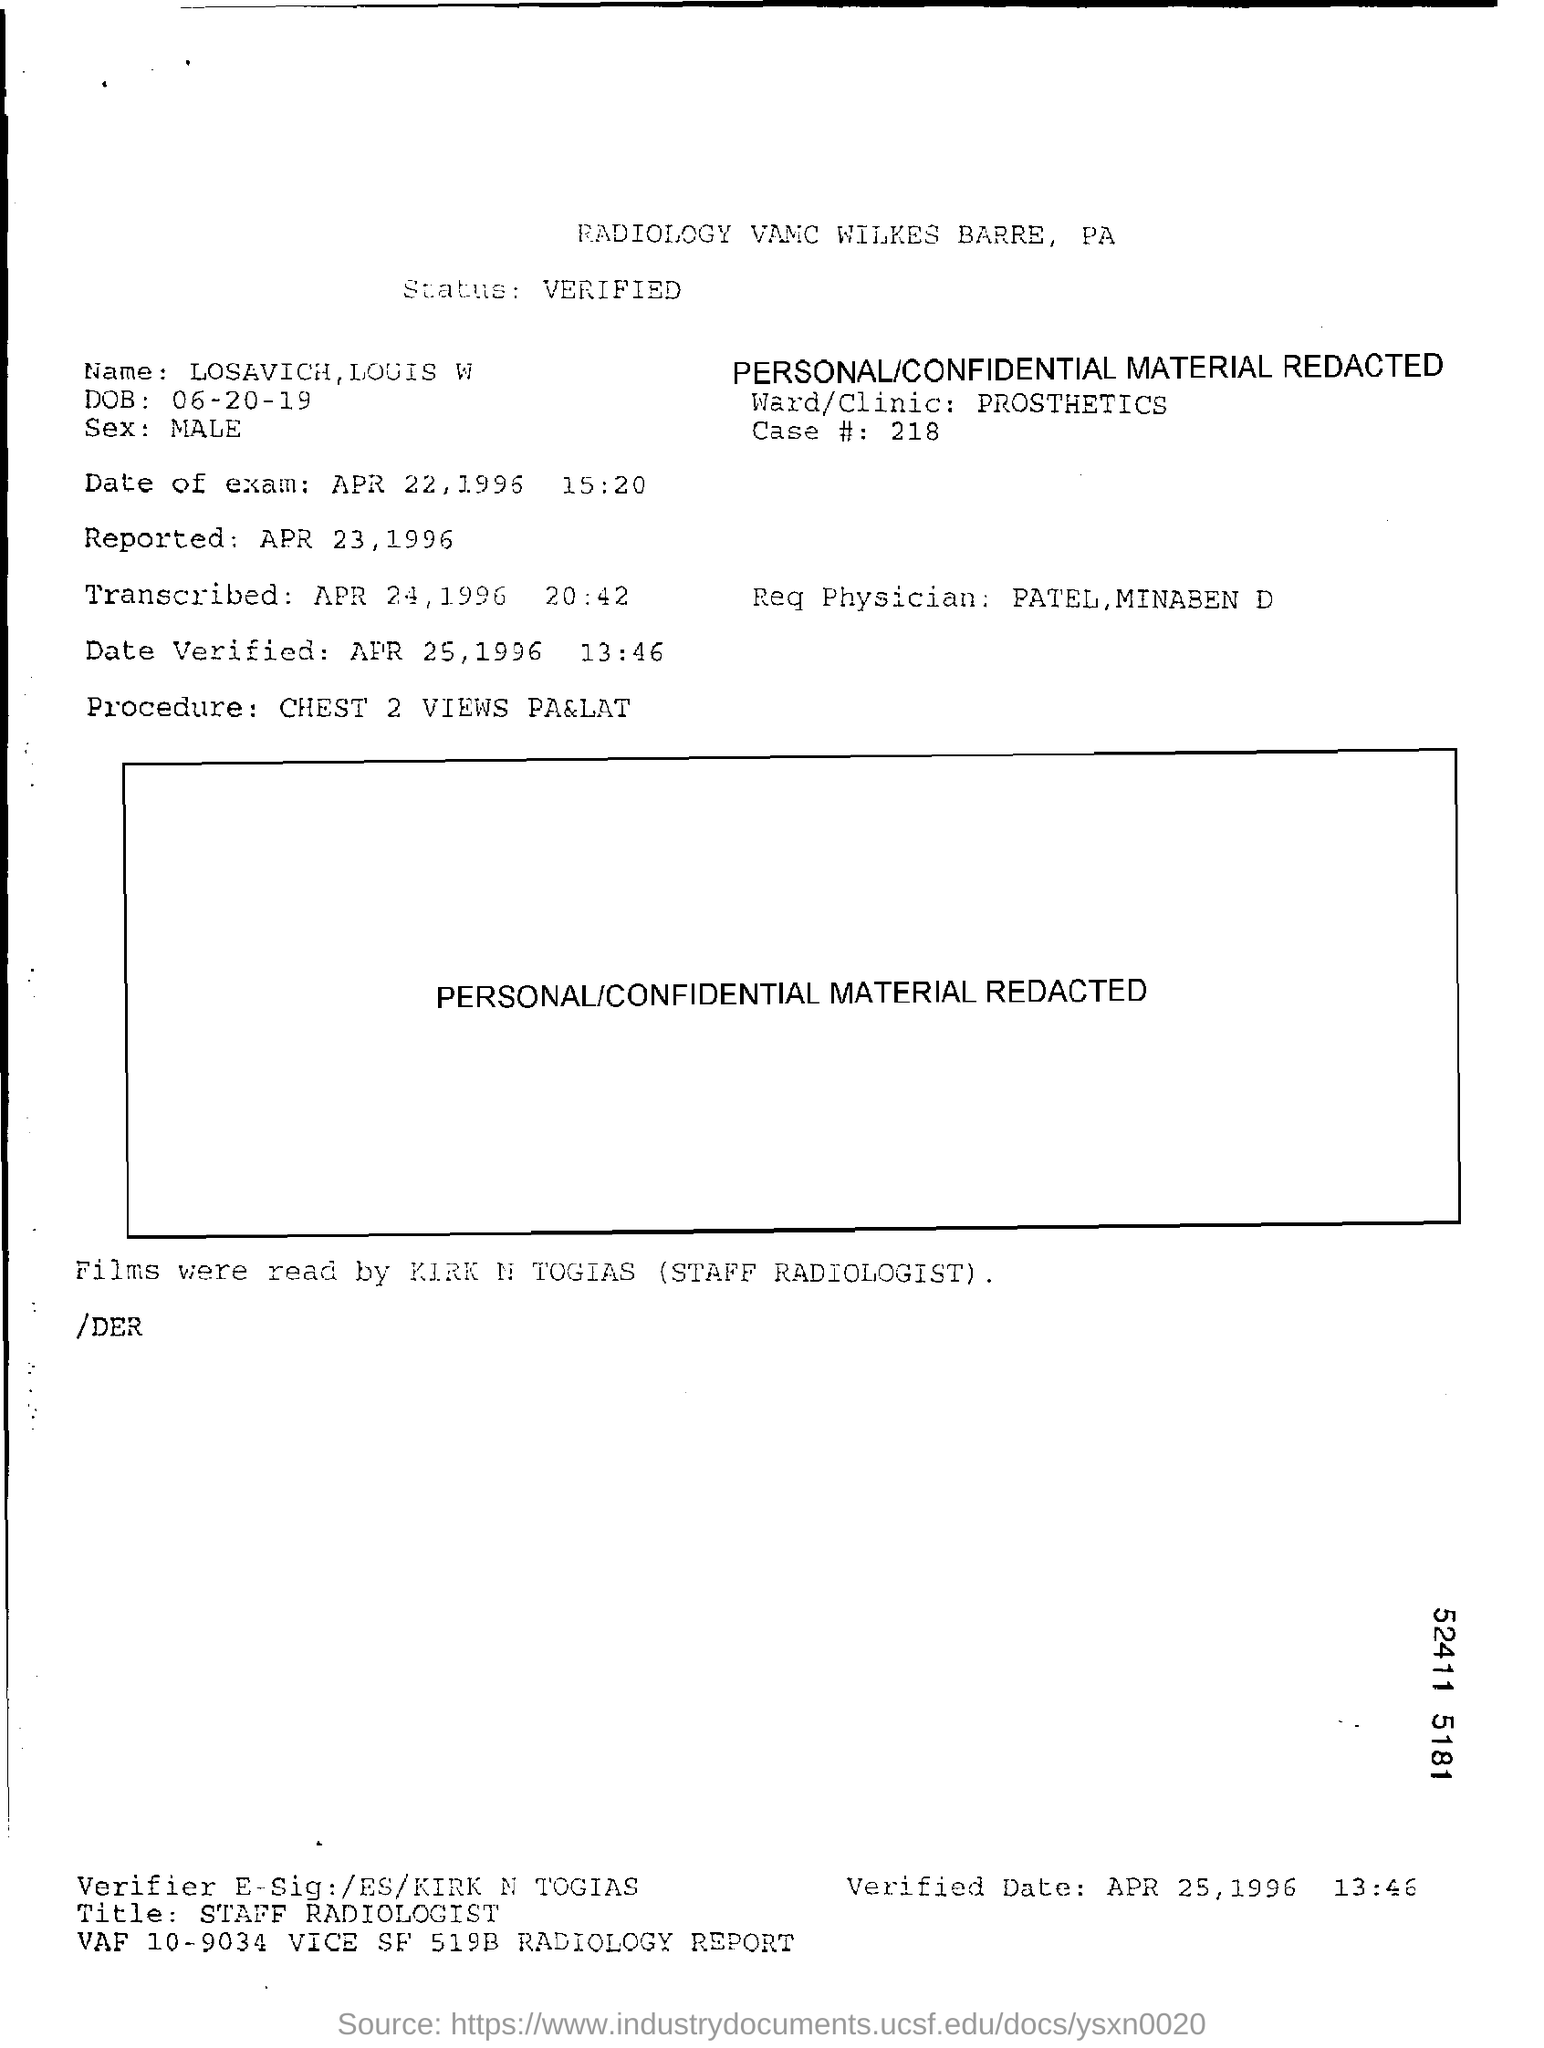What is the status?
Provide a succinct answer. Verified. What is the Name?
Keep it short and to the point. Losavich, louis w. What is the DOB?
Give a very brief answer. 06-20-19. What is the sex?
Offer a very short reply. Male. What is the Case #?
Provide a short and direct response. 218. What is the date of exam?
Offer a very short reply. APR 22, 1996. When was it reported?
Provide a short and direct response. Apr 23, 1996. Who is the Req Physician?
Your answer should be compact. Patel, minaben d. When was the date verified?
Offer a terse response. APR 25, 1996. What is the Procedure?
Provide a short and direct response. Chest 2 Views PA&LAT. 